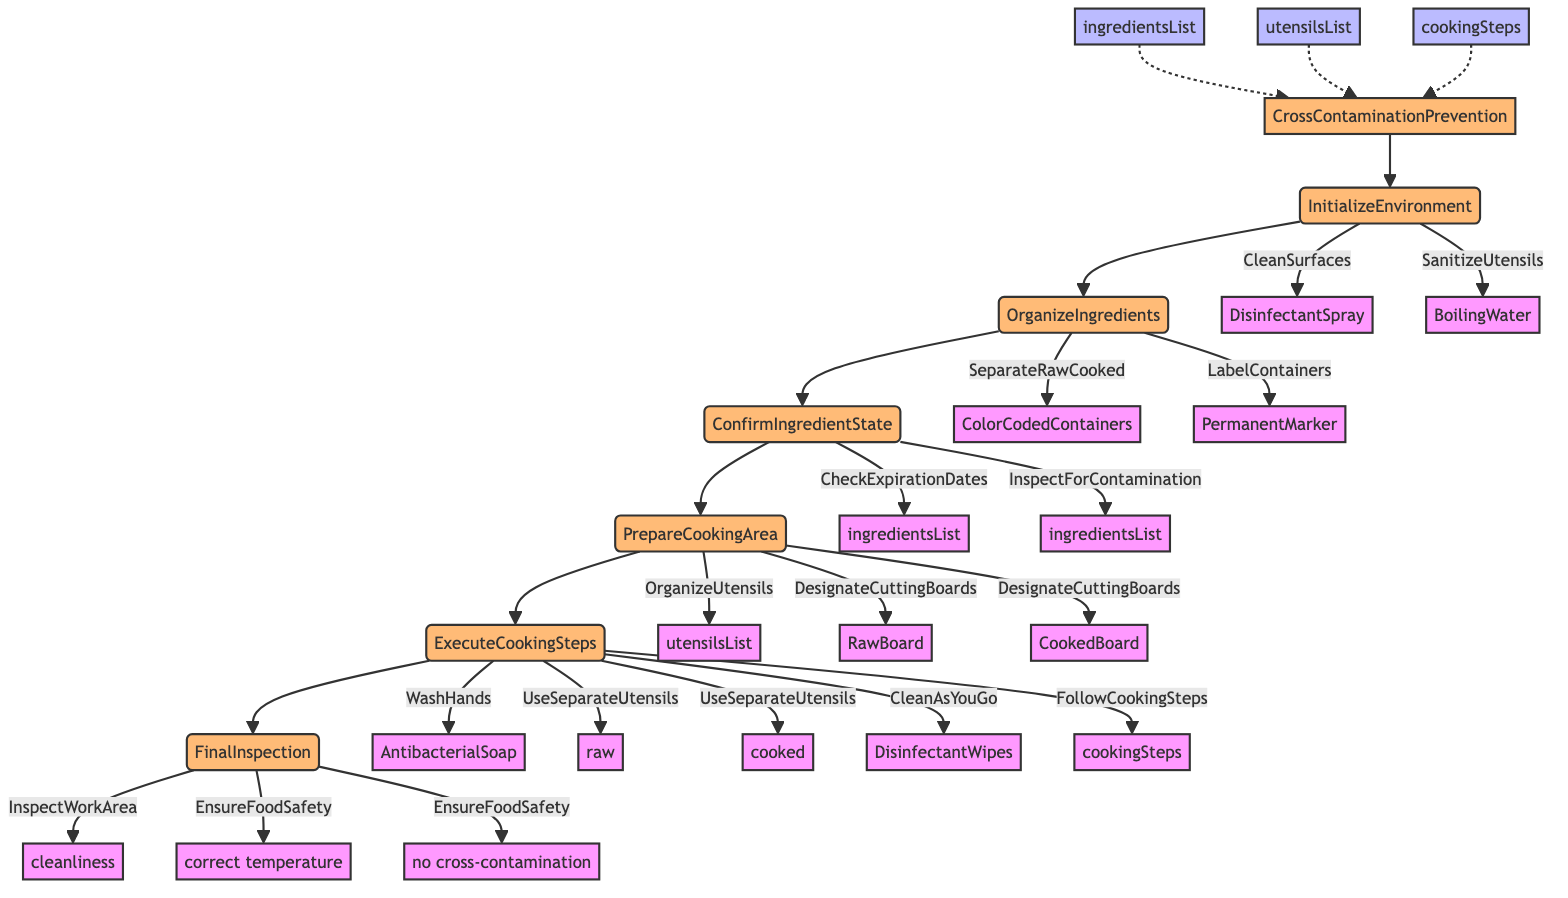What is the first step in the process? The diagram shows that the first step is "InitializeEnvironment." This is the only step that directly follows the function name in the flowchart, indicating it is the starting point of the process.
Answer: InitializeEnvironment How many actions are there in the "PrepareCookingArea" step? The "PrepareCookingArea" step has two actions listed: "OrganizeUtensils" and "DesignateCuttingBoards." Counting these gives the total of two actions for this step.
Answer: 2 What tool is used to sanitize utensils? In the "InitializeEnvironment" step, the tool specified for sanitizing utensils is "BoilingWater." This is explicitly stated along with the associated action.
Answer: BoilingWater Which steps come after "OrganizeIngredients"? The flowchart indicates that the step following "OrganizeIngredients" is "ConfirmIngredientState." Following the arrows in the diagram shows the direct connection from one step to the next.
Answer: ConfirmIngredientState What is the last action in the "ExecuteCookingSteps"? The last action listed in the "ExecuteCookingSteps" section is "FollowCookingSteps," which indicates the final procedure to be performed in that step.
Answer: FollowCookingSteps How many input lists are required for the function? There are three input lists required for the function: "ingredientsList," "utensilsList," and "cookingSteps." Each is clearly indicated as an input connected to the main function.
Answer: 3 What criteria are checked in the "FinalInspection"? The "FinalInspection" step checks the criteria of "cleanliness" and ensures "correct temperature, no cross-contamination." These criteria ensure all safety standards are upheld.
Answer: cleanliness, correct temperature, no cross-contamination What tool is used for cleaning as you go? In the "ExecuteCookingSteps," the tool specified for cleaning as you go is "DisinfectantWipes." This action is highlighted as part of maintaining cleanliness during cooking.
Answer: DisinfectantWipes What is the action taken to confirm ingredient safety? The actions taken to confirm ingredient safety are "CheckExpirationDates" and "InspectForContamination." Both actions are vital for ensuring that the ingredients are safe for use.
Answer: CheckExpirationDates, InspectForContamination 